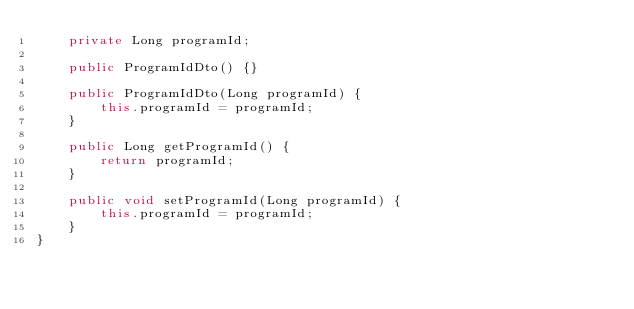Convert code to text. <code><loc_0><loc_0><loc_500><loc_500><_Java_>	private Long programId;

	public ProgramIdDto() {}

	public ProgramIdDto(Long programId) {
		this.programId = programId;
	}

	public Long getProgramId() {
		return programId;
	}

	public void setProgramId(Long programId) {
		this.programId = programId;
	}
}
</code> 